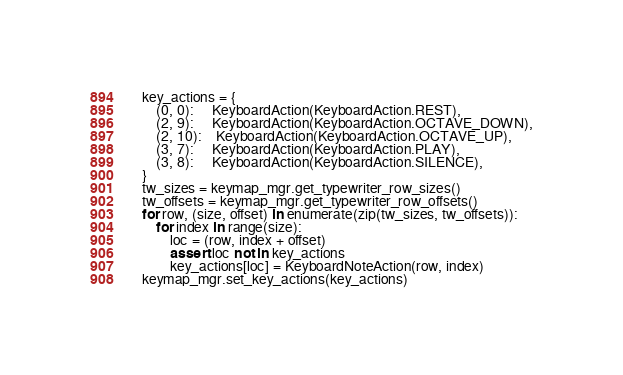Convert code to text. <code><loc_0><loc_0><loc_500><loc_500><_Python_>    key_actions = {
        (0, 0):     KeyboardAction(KeyboardAction.REST),
        (2, 9):     KeyboardAction(KeyboardAction.OCTAVE_DOWN),
        (2, 10):    KeyboardAction(KeyboardAction.OCTAVE_UP),
        (3, 7):     KeyboardAction(KeyboardAction.PLAY),
        (3, 8):     KeyboardAction(KeyboardAction.SILENCE),
    }
    tw_sizes = keymap_mgr.get_typewriter_row_sizes()
    tw_offsets = keymap_mgr.get_typewriter_row_offsets()
    for row, (size, offset) in enumerate(zip(tw_sizes, tw_offsets)):
        for index in range(size):
            loc = (row, index + offset)
            assert loc not in key_actions
            key_actions[loc] = KeyboardNoteAction(row, index)
    keymap_mgr.set_key_actions(key_actions)


</code> 